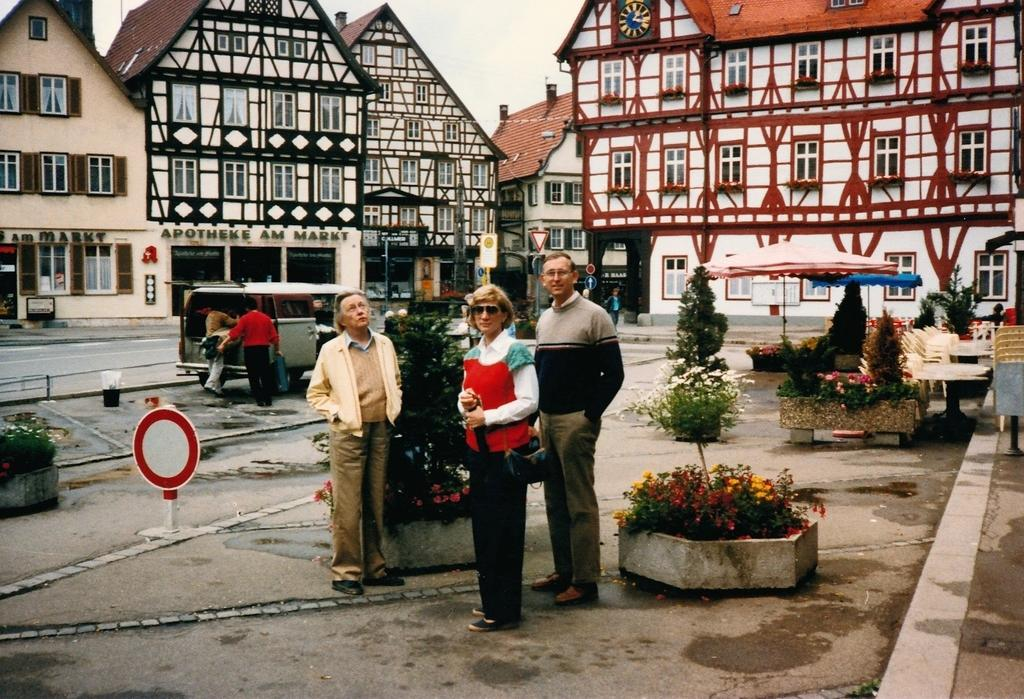How many people are in the image? There are three people in the image: two old men and a woman. What are the people in the image doing? The people are standing and posing for the camera. What can be seen in the background of the image? There is a silver-colored van and 3D design roof houses visible in the background. How many leaves are on the ground in the image? There are no leaves visible on the ground in the image. What type of clocks can be seen hanging on the wall in the image? There are no clocks visible in the image. 